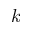<formula> <loc_0><loc_0><loc_500><loc_500>k</formula> 